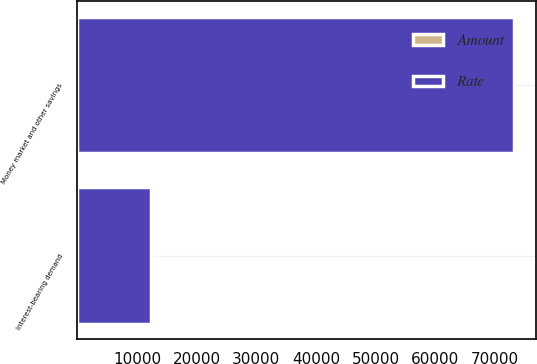Convert chart to OTSL. <chart><loc_0><loc_0><loc_500><loc_500><stacked_bar_chart><ecel><fcel>Money market and other savings<fcel>Interest-bearing demand<nl><fcel>Rate<fcel>73167<fcel>12298<nl><fcel>Amount<fcel>0.03<fcel>0.1<nl></chart> 